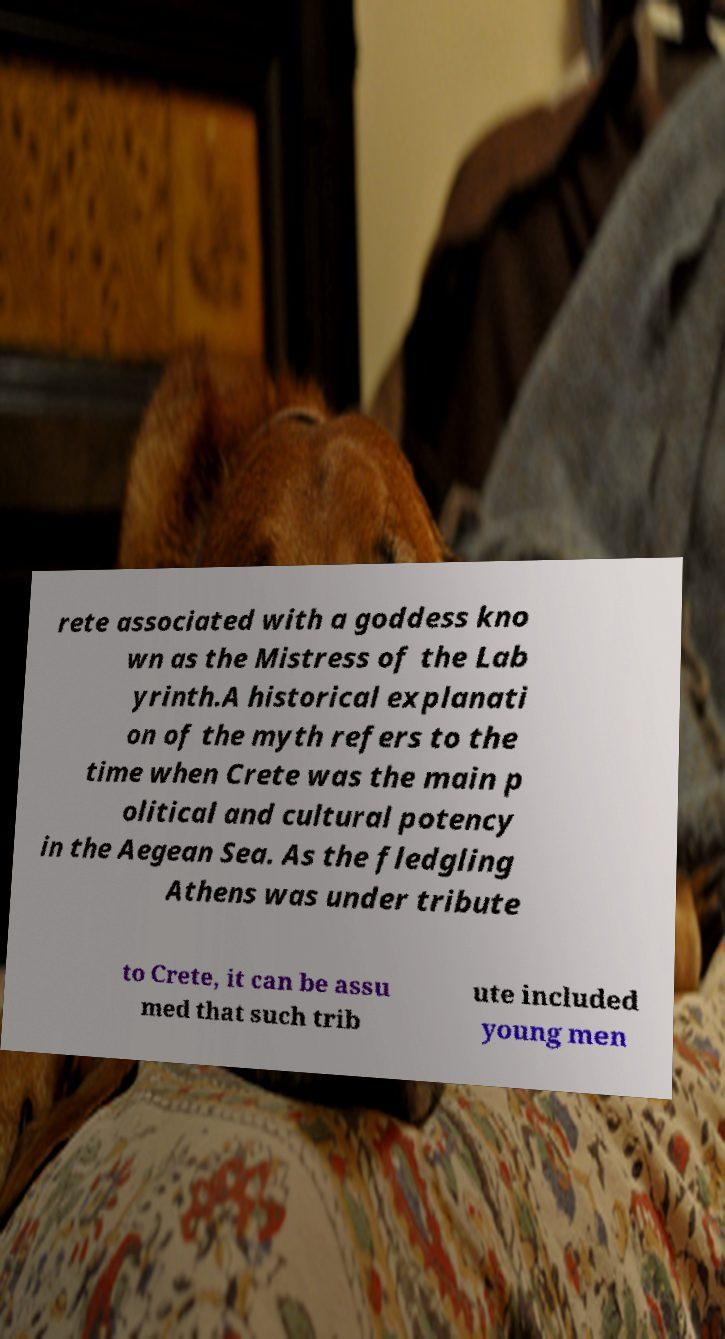Can you read and provide the text displayed in the image?This photo seems to have some interesting text. Can you extract and type it out for me? rete associated with a goddess kno wn as the Mistress of the Lab yrinth.A historical explanati on of the myth refers to the time when Crete was the main p olitical and cultural potency in the Aegean Sea. As the fledgling Athens was under tribute to Crete, it can be assu med that such trib ute included young men 